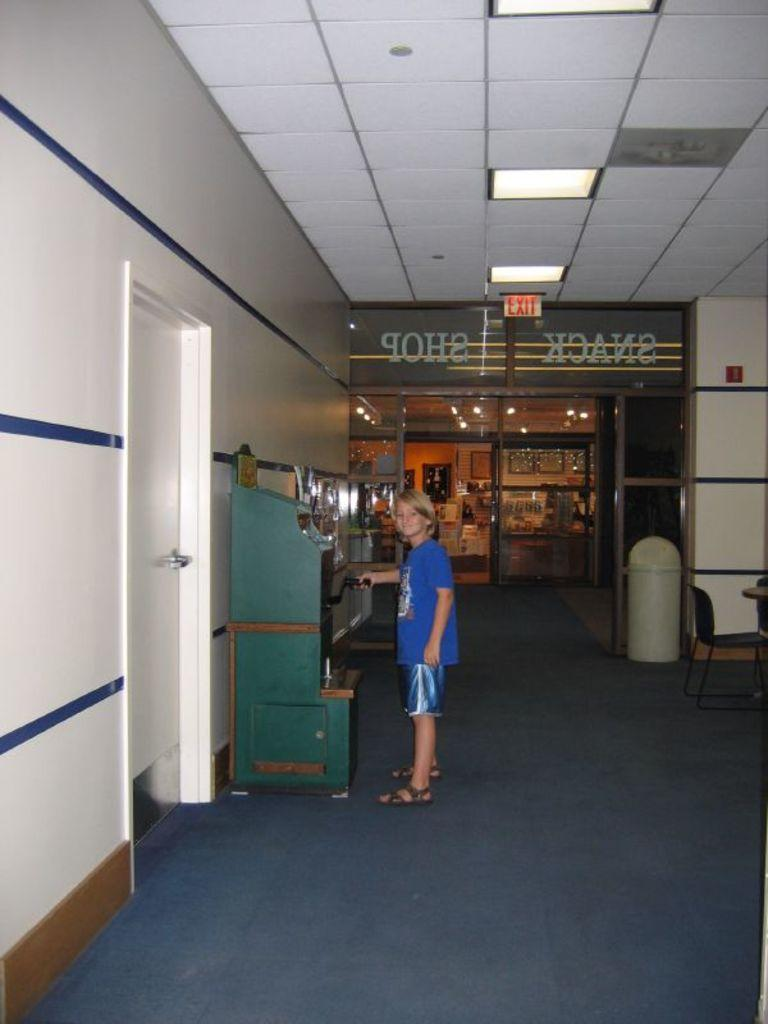What type of structure can be seen in the image? There is a wall in the image. Is there any entrance visible in the image? Yes, there is a door in the image. Can you describe the person in the image? There is a person standing in the image. What type of container is present in the image? There is a dustbin in the image. What additional feature can be seen in the image? There is a banner in the image. What can be used for illumination in the image? There are lights in the image. What type of base is supporting the person in the image? There is no base mentioned or visible in the image; the person is standing on the ground. Is there any blood visible in the image? No, there is no blood visible in the image. 